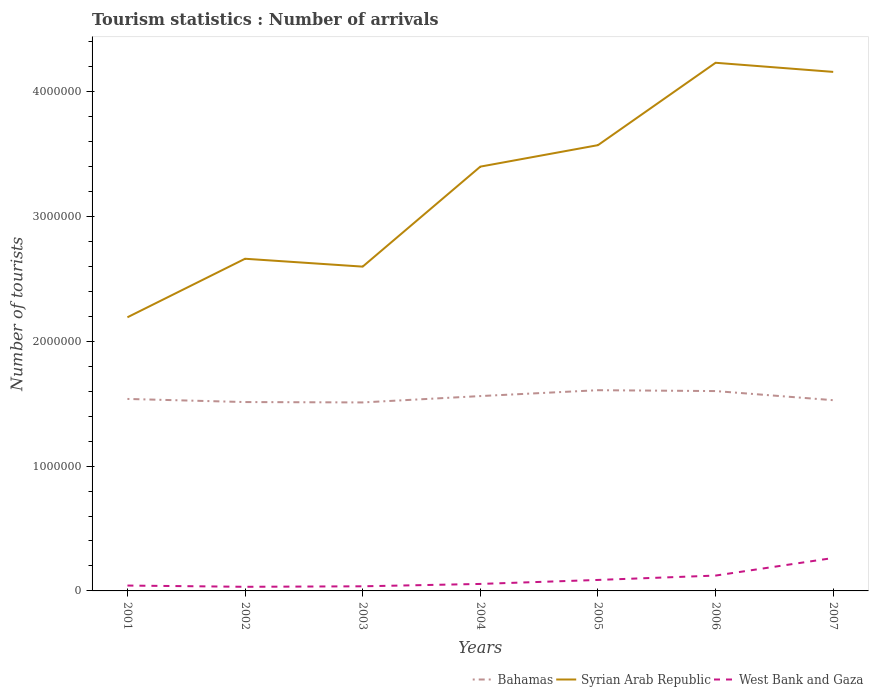Does the line corresponding to West Bank and Gaza intersect with the line corresponding to Syrian Arab Republic?
Your answer should be compact. No. Is the number of lines equal to the number of legend labels?
Make the answer very short. Yes. Across all years, what is the maximum number of tourist arrivals in Syrian Arab Republic?
Make the answer very short. 2.19e+06. What is the total number of tourist arrivals in West Bank and Gaza in the graph?
Your answer should be very brief. -4000. What is the difference between the highest and the second highest number of tourist arrivals in West Bank and Gaza?
Offer a very short reply. 2.31e+05. How many years are there in the graph?
Make the answer very short. 7. Does the graph contain any zero values?
Provide a short and direct response. No. Does the graph contain grids?
Provide a short and direct response. No. How many legend labels are there?
Keep it short and to the point. 3. What is the title of the graph?
Provide a succinct answer. Tourism statistics : Number of arrivals. Does "Suriname" appear as one of the legend labels in the graph?
Give a very brief answer. No. What is the label or title of the Y-axis?
Give a very brief answer. Number of tourists. What is the Number of tourists of Bahamas in 2001?
Offer a very short reply. 1.54e+06. What is the Number of tourists of Syrian Arab Republic in 2001?
Offer a terse response. 2.19e+06. What is the Number of tourists in West Bank and Gaza in 2001?
Provide a succinct answer. 4.30e+04. What is the Number of tourists of Bahamas in 2002?
Offer a terse response. 1.51e+06. What is the Number of tourists of Syrian Arab Republic in 2002?
Ensure brevity in your answer.  2.66e+06. What is the Number of tourists of West Bank and Gaza in 2002?
Keep it short and to the point. 3.30e+04. What is the Number of tourists in Bahamas in 2003?
Offer a terse response. 1.51e+06. What is the Number of tourists in Syrian Arab Republic in 2003?
Your answer should be very brief. 2.60e+06. What is the Number of tourists in West Bank and Gaza in 2003?
Offer a terse response. 3.70e+04. What is the Number of tourists in Bahamas in 2004?
Make the answer very short. 1.56e+06. What is the Number of tourists in Syrian Arab Republic in 2004?
Your response must be concise. 3.40e+06. What is the Number of tourists of West Bank and Gaza in 2004?
Ensure brevity in your answer.  5.60e+04. What is the Number of tourists in Bahamas in 2005?
Your answer should be very brief. 1.61e+06. What is the Number of tourists in Syrian Arab Republic in 2005?
Provide a short and direct response. 3.57e+06. What is the Number of tourists of West Bank and Gaza in 2005?
Your response must be concise. 8.80e+04. What is the Number of tourists in Bahamas in 2006?
Keep it short and to the point. 1.60e+06. What is the Number of tourists in Syrian Arab Republic in 2006?
Your response must be concise. 4.23e+06. What is the Number of tourists in West Bank and Gaza in 2006?
Provide a succinct answer. 1.23e+05. What is the Number of tourists in Bahamas in 2007?
Your answer should be very brief. 1.53e+06. What is the Number of tourists of Syrian Arab Republic in 2007?
Offer a terse response. 4.16e+06. What is the Number of tourists in West Bank and Gaza in 2007?
Your answer should be compact. 2.64e+05. Across all years, what is the maximum Number of tourists in Bahamas?
Your answer should be compact. 1.61e+06. Across all years, what is the maximum Number of tourists of Syrian Arab Republic?
Your response must be concise. 4.23e+06. Across all years, what is the maximum Number of tourists of West Bank and Gaza?
Provide a succinct answer. 2.64e+05. Across all years, what is the minimum Number of tourists of Bahamas?
Ensure brevity in your answer.  1.51e+06. Across all years, what is the minimum Number of tourists in Syrian Arab Republic?
Give a very brief answer. 2.19e+06. Across all years, what is the minimum Number of tourists in West Bank and Gaza?
Your answer should be very brief. 3.30e+04. What is the total Number of tourists of Bahamas in the graph?
Keep it short and to the point. 1.09e+07. What is the total Number of tourists in Syrian Arab Republic in the graph?
Provide a short and direct response. 2.28e+07. What is the total Number of tourists in West Bank and Gaza in the graph?
Your answer should be very brief. 6.44e+05. What is the difference between the Number of tourists in Bahamas in 2001 and that in 2002?
Give a very brief answer. 2.50e+04. What is the difference between the Number of tourists in Syrian Arab Republic in 2001 and that in 2002?
Your answer should be compact. -4.69e+05. What is the difference between the Number of tourists in West Bank and Gaza in 2001 and that in 2002?
Provide a short and direct response. 10000. What is the difference between the Number of tourists of Bahamas in 2001 and that in 2003?
Give a very brief answer. 2.80e+04. What is the difference between the Number of tourists in Syrian Arab Republic in 2001 and that in 2003?
Offer a very short reply. -4.06e+05. What is the difference between the Number of tourists in West Bank and Gaza in 2001 and that in 2003?
Provide a succinct answer. 6000. What is the difference between the Number of tourists in Bahamas in 2001 and that in 2004?
Ensure brevity in your answer.  -2.30e+04. What is the difference between the Number of tourists of Syrian Arab Republic in 2001 and that in 2004?
Offer a very short reply. -1.21e+06. What is the difference between the Number of tourists of West Bank and Gaza in 2001 and that in 2004?
Your answer should be compact. -1.30e+04. What is the difference between the Number of tourists of Syrian Arab Republic in 2001 and that in 2005?
Make the answer very short. -1.38e+06. What is the difference between the Number of tourists in West Bank and Gaza in 2001 and that in 2005?
Provide a short and direct response. -4.50e+04. What is the difference between the Number of tourists of Bahamas in 2001 and that in 2006?
Your answer should be very brief. -6.30e+04. What is the difference between the Number of tourists of Syrian Arab Republic in 2001 and that in 2006?
Your response must be concise. -2.04e+06. What is the difference between the Number of tourists in Syrian Arab Republic in 2001 and that in 2007?
Keep it short and to the point. -1.97e+06. What is the difference between the Number of tourists of West Bank and Gaza in 2001 and that in 2007?
Ensure brevity in your answer.  -2.21e+05. What is the difference between the Number of tourists in Bahamas in 2002 and that in 2003?
Offer a terse response. 3000. What is the difference between the Number of tourists of Syrian Arab Republic in 2002 and that in 2003?
Your answer should be very brief. 6.30e+04. What is the difference between the Number of tourists of West Bank and Gaza in 2002 and that in 2003?
Provide a short and direct response. -4000. What is the difference between the Number of tourists of Bahamas in 2002 and that in 2004?
Your response must be concise. -4.80e+04. What is the difference between the Number of tourists in Syrian Arab Republic in 2002 and that in 2004?
Provide a short and direct response. -7.38e+05. What is the difference between the Number of tourists of West Bank and Gaza in 2002 and that in 2004?
Your answer should be compact. -2.30e+04. What is the difference between the Number of tourists in Bahamas in 2002 and that in 2005?
Provide a succinct answer. -9.50e+04. What is the difference between the Number of tourists in Syrian Arab Republic in 2002 and that in 2005?
Make the answer very short. -9.10e+05. What is the difference between the Number of tourists of West Bank and Gaza in 2002 and that in 2005?
Your response must be concise. -5.50e+04. What is the difference between the Number of tourists of Bahamas in 2002 and that in 2006?
Ensure brevity in your answer.  -8.80e+04. What is the difference between the Number of tourists of Syrian Arab Republic in 2002 and that in 2006?
Provide a short and direct response. -1.57e+06. What is the difference between the Number of tourists in West Bank and Gaza in 2002 and that in 2006?
Make the answer very short. -9.00e+04. What is the difference between the Number of tourists in Bahamas in 2002 and that in 2007?
Offer a terse response. -1.50e+04. What is the difference between the Number of tourists of Syrian Arab Republic in 2002 and that in 2007?
Provide a succinct answer. -1.50e+06. What is the difference between the Number of tourists of West Bank and Gaza in 2002 and that in 2007?
Offer a terse response. -2.31e+05. What is the difference between the Number of tourists of Bahamas in 2003 and that in 2004?
Provide a succinct answer. -5.10e+04. What is the difference between the Number of tourists of Syrian Arab Republic in 2003 and that in 2004?
Make the answer very short. -8.01e+05. What is the difference between the Number of tourists in West Bank and Gaza in 2003 and that in 2004?
Your answer should be compact. -1.90e+04. What is the difference between the Number of tourists of Bahamas in 2003 and that in 2005?
Provide a short and direct response. -9.80e+04. What is the difference between the Number of tourists in Syrian Arab Republic in 2003 and that in 2005?
Give a very brief answer. -9.73e+05. What is the difference between the Number of tourists of West Bank and Gaza in 2003 and that in 2005?
Your answer should be compact. -5.10e+04. What is the difference between the Number of tourists in Bahamas in 2003 and that in 2006?
Provide a short and direct response. -9.10e+04. What is the difference between the Number of tourists in Syrian Arab Republic in 2003 and that in 2006?
Offer a very short reply. -1.63e+06. What is the difference between the Number of tourists of West Bank and Gaza in 2003 and that in 2006?
Offer a very short reply. -8.60e+04. What is the difference between the Number of tourists of Bahamas in 2003 and that in 2007?
Keep it short and to the point. -1.80e+04. What is the difference between the Number of tourists of Syrian Arab Republic in 2003 and that in 2007?
Give a very brief answer. -1.56e+06. What is the difference between the Number of tourists in West Bank and Gaza in 2003 and that in 2007?
Your answer should be very brief. -2.27e+05. What is the difference between the Number of tourists in Bahamas in 2004 and that in 2005?
Give a very brief answer. -4.70e+04. What is the difference between the Number of tourists of Syrian Arab Republic in 2004 and that in 2005?
Your answer should be very brief. -1.72e+05. What is the difference between the Number of tourists in West Bank and Gaza in 2004 and that in 2005?
Offer a terse response. -3.20e+04. What is the difference between the Number of tourists in Syrian Arab Republic in 2004 and that in 2006?
Provide a short and direct response. -8.32e+05. What is the difference between the Number of tourists in West Bank and Gaza in 2004 and that in 2006?
Keep it short and to the point. -6.70e+04. What is the difference between the Number of tourists in Bahamas in 2004 and that in 2007?
Offer a terse response. 3.30e+04. What is the difference between the Number of tourists of Syrian Arab Republic in 2004 and that in 2007?
Provide a short and direct response. -7.59e+05. What is the difference between the Number of tourists of West Bank and Gaza in 2004 and that in 2007?
Your answer should be very brief. -2.08e+05. What is the difference between the Number of tourists in Bahamas in 2005 and that in 2006?
Your response must be concise. 7000. What is the difference between the Number of tourists of Syrian Arab Republic in 2005 and that in 2006?
Offer a very short reply. -6.60e+05. What is the difference between the Number of tourists in West Bank and Gaza in 2005 and that in 2006?
Your answer should be compact. -3.50e+04. What is the difference between the Number of tourists in Syrian Arab Republic in 2005 and that in 2007?
Provide a succinct answer. -5.87e+05. What is the difference between the Number of tourists in West Bank and Gaza in 2005 and that in 2007?
Offer a very short reply. -1.76e+05. What is the difference between the Number of tourists in Bahamas in 2006 and that in 2007?
Make the answer very short. 7.30e+04. What is the difference between the Number of tourists in Syrian Arab Republic in 2006 and that in 2007?
Offer a terse response. 7.30e+04. What is the difference between the Number of tourists of West Bank and Gaza in 2006 and that in 2007?
Keep it short and to the point. -1.41e+05. What is the difference between the Number of tourists of Bahamas in 2001 and the Number of tourists of Syrian Arab Republic in 2002?
Ensure brevity in your answer.  -1.12e+06. What is the difference between the Number of tourists of Bahamas in 2001 and the Number of tourists of West Bank and Gaza in 2002?
Make the answer very short. 1.50e+06. What is the difference between the Number of tourists of Syrian Arab Republic in 2001 and the Number of tourists of West Bank and Gaza in 2002?
Give a very brief answer. 2.16e+06. What is the difference between the Number of tourists in Bahamas in 2001 and the Number of tourists in Syrian Arab Republic in 2003?
Provide a succinct answer. -1.06e+06. What is the difference between the Number of tourists in Bahamas in 2001 and the Number of tourists in West Bank and Gaza in 2003?
Make the answer very short. 1.50e+06. What is the difference between the Number of tourists in Syrian Arab Republic in 2001 and the Number of tourists in West Bank and Gaza in 2003?
Provide a succinct answer. 2.16e+06. What is the difference between the Number of tourists in Bahamas in 2001 and the Number of tourists in Syrian Arab Republic in 2004?
Give a very brief answer. -1.86e+06. What is the difference between the Number of tourists of Bahamas in 2001 and the Number of tourists of West Bank and Gaza in 2004?
Make the answer very short. 1.48e+06. What is the difference between the Number of tourists in Syrian Arab Republic in 2001 and the Number of tourists in West Bank and Gaza in 2004?
Provide a succinct answer. 2.14e+06. What is the difference between the Number of tourists in Bahamas in 2001 and the Number of tourists in Syrian Arab Republic in 2005?
Your answer should be compact. -2.03e+06. What is the difference between the Number of tourists in Bahamas in 2001 and the Number of tourists in West Bank and Gaza in 2005?
Your response must be concise. 1.45e+06. What is the difference between the Number of tourists in Syrian Arab Republic in 2001 and the Number of tourists in West Bank and Gaza in 2005?
Your answer should be compact. 2.10e+06. What is the difference between the Number of tourists of Bahamas in 2001 and the Number of tourists of Syrian Arab Republic in 2006?
Make the answer very short. -2.69e+06. What is the difference between the Number of tourists of Bahamas in 2001 and the Number of tourists of West Bank and Gaza in 2006?
Your response must be concise. 1.42e+06. What is the difference between the Number of tourists of Syrian Arab Republic in 2001 and the Number of tourists of West Bank and Gaza in 2006?
Keep it short and to the point. 2.07e+06. What is the difference between the Number of tourists in Bahamas in 2001 and the Number of tourists in Syrian Arab Republic in 2007?
Your answer should be very brief. -2.62e+06. What is the difference between the Number of tourists in Bahamas in 2001 and the Number of tourists in West Bank and Gaza in 2007?
Offer a very short reply. 1.27e+06. What is the difference between the Number of tourists in Syrian Arab Republic in 2001 and the Number of tourists in West Bank and Gaza in 2007?
Keep it short and to the point. 1.93e+06. What is the difference between the Number of tourists in Bahamas in 2002 and the Number of tourists in Syrian Arab Republic in 2003?
Give a very brief answer. -1.08e+06. What is the difference between the Number of tourists of Bahamas in 2002 and the Number of tourists of West Bank and Gaza in 2003?
Provide a short and direct response. 1.48e+06. What is the difference between the Number of tourists in Syrian Arab Republic in 2002 and the Number of tourists in West Bank and Gaza in 2003?
Keep it short and to the point. 2.62e+06. What is the difference between the Number of tourists of Bahamas in 2002 and the Number of tourists of Syrian Arab Republic in 2004?
Offer a very short reply. -1.89e+06. What is the difference between the Number of tourists of Bahamas in 2002 and the Number of tourists of West Bank and Gaza in 2004?
Your answer should be very brief. 1.46e+06. What is the difference between the Number of tourists of Syrian Arab Republic in 2002 and the Number of tourists of West Bank and Gaza in 2004?
Make the answer very short. 2.60e+06. What is the difference between the Number of tourists in Bahamas in 2002 and the Number of tourists in Syrian Arab Republic in 2005?
Offer a very short reply. -2.06e+06. What is the difference between the Number of tourists of Bahamas in 2002 and the Number of tourists of West Bank and Gaza in 2005?
Provide a short and direct response. 1.42e+06. What is the difference between the Number of tourists of Syrian Arab Republic in 2002 and the Number of tourists of West Bank and Gaza in 2005?
Make the answer very short. 2.57e+06. What is the difference between the Number of tourists in Bahamas in 2002 and the Number of tourists in Syrian Arab Republic in 2006?
Give a very brief answer. -2.72e+06. What is the difference between the Number of tourists in Bahamas in 2002 and the Number of tourists in West Bank and Gaza in 2006?
Offer a very short reply. 1.39e+06. What is the difference between the Number of tourists of Syrian Arab Republic in 2002 and the Number of tourists of West Bank and Gaza in 2006?
Your answer should be very brief. 2.54e+06. What is the difference between the Number of tourists in Bahamas in 2002 and the Number of tourists in Syrian Arab Republic in 2007?
Keep it short and to the point. -2.64e+06. What is the difference between the Number of tourists of Bahamas in 2002 and the Number of tourists of West Bank and Gaza in 2007?
Give a very brief answer. 1.25e+06. What is the difference between the Number of tourists of Syrian Arab Republic in 2002 and the Number of tourists of West Bank and Gaza in 2007?
Your answer should be compact. 2.40e+06. What is the difference between the Number of tourists in Bahamas in 2003 and the Number of tourists in Syrian Arab Republic in 2004?
Provide a succinct answer. -1.89e+06. What is the difference between the Number of tourists in Bahamas in 2003 and the Number of tourists in West Bank and Gaza in 2004?
Offer a terse response. 1.45e+06. What is the difference between the Number of tourists in Syrian Arab Republic in 2003 and the Number of tourists in West Bank and Gaza in 2004?
Give a very brief answer. 2.54e+06. What is the difference between the Number of tourists of Bahamas in 2003 and the Number of tourists of Syrian Arab Republic in 2005?
Keep it short and to the point. -2.06e+06. What is the difference between the Number of tourists in Bahamas in 2003 and the Number of tourists in West Bank and Gaza in 2005?
Your answer should be very brief. 1.42e+06. What is the difference between the Number of tourists in Syrian Arab Republic in 2003 and the Number of tourists in West Bank and Gaza in 2005?
Offer a terse response. 2.51e+06. What is the difference between the Number of tourists in Bahamas in 2003 and the Number of tourists in Syrian Arab Republic in 2006?
Offer a very short reply. -2.72e+06. What is the difference between the Number of tourists in Bahamas in 2003 and the Number of tourists in West Bank and Gaza in 2006?
Give a very brief answer. 1.39e+06. What is the difference between the Number of tourists of Syrian Arab Republic in 2003 and the Number of tourists of West Bank and Gaza in 2006?
Offer a very short reply. 2.48e+06. What is the difference between the Number of tourists in Bahamas in 2003 and the Number of tourists in Syrian Arab Republic in 2007?
Keep it short and to the point. -2.65e+06. What is the difference between the Number of tourists of Bahamas in 2003 and the Number of tourists of West Bank and Gaza in 2007?
Provide a succinct answer. 1.25e+06. What is the difference between the Number of tourists in Syrian Arab Republic in 2003 and the Number of tourists in West Bank and Gaza in 2007?
Your response must be concise. 2.33e+06. What is the difference between the Number of tourists of Bahamas in 2004 and the Number of tourists of Syrian Arab Republic in 2005?
Ensure brevity in your answer.  -2.01e+06. What is the difference between the Number of tourists in Bahamas in 2004 and the Number of tourists in West Bank and Gaza in 2005?
Ensure brevity in your answer.  1.47e+06. What is the difference between the Number of tourists in Syrian Arab Republic in 2004 and the Number of tourists in West Bank and Gaza in 2005?
Keep it short and to the point. 3.31e+06. What is the difference between the Number of tourists in Bahamas in 2004 and the Number of tourists in Syrian Arab Republic in 2006?
Your answer should be compact. -2.67e+06. What is the difference between the Number of tourists in Bahamas in 2004 and the Number of tourists in West Bank and Gaza in 2006?
Offer a very short reply. 1.44e+06. What is the difference between the Number of tourists of Syrian Arab Republic in 2004 and the Number of tourists of West Bank and Gaza in 2006?
Your answer should be compact. 3.28e+06. What is the difference between the Number of tourists in Bahamas in 2004 and the Number of tourists in Syrian Arab Republic in 2007?
Your response must be concise. -2.60e+06. What is the difference between the Number of tourists in Bahamas in 2004 and the Number of tourists in West Bank and Gaza in 2007?
Keep it short and to the point. 1.30e+06. What is the difference between the Number of tourists in Syrian Arab Republic in 2004 and the Number of tourists in West Bank and Gaza in 2007?
Your answer should be compact. 3.14e+06. What is the difference between the Number of tourists in Bahamas in 2005 and the Number of tourists in Syrian Arab Republic in 2006?
Ensure brevity in your answer.  -2.62e+06. What is the difference between the Number of tourists of Bahamas in 2005 and the Number of tourists of West Bank and Gaza in 2006?
Keep it short and to the point. 1.48e+06. What is the difference between the Number of tourists in Syrian Arab Republic in 2005 and the Number of tourists in West Bank and Gaza in 2006?
Ensure brevity in your answer.  3.45e+06. What is the difference between the Number of tourists of Bahamas in 2005 and the Number of tourists of Syrian Arab Republic in 2007?
Make the answer very short. -2.55e+06. What is the difference between the Number of tourists in Bahamas in 2005 and the Number of tourists in West Bank and Gaza in 2007?
Offer a terse response. 1.34e+06. What is the difference between the Number of tourists in Syrian Arab Republic in 2005 and the Number of tourists in West Bank and Gaza in 2007?
Provide a short and direct response. 3.31e+06. What is the difference between the Number of tourists of Bahamas in 2006 and the Number of tourists of Syrian Arab Republic in 2007?
Offer a terse response. -2.56e+06. What is the difference between the Number of tourists in Bahamas in 2006 and the Number of tourists in West Bank and Gaza in 2007?
Your answer should be compact. 1.34e+06. What is the difference between the Number of tourists of Syrian Arab Republic in 2006 and the Number of tourists of West Bank and Gaza in 2007?
Offer a terse response. 3.97e+06. What is the average Number of tourists in Bahamas per year?
Provide a succinct answer. 1.55e+06. What is the average Number of tourists in Syrian Arab Republic per year?
Provide a succinct answer. 3.26e+06. What is the average Number of tourists in West Bank and Gaza per year?
Give a very brief answer. 9.20e+04. In the year 2001, what is the difference between the Number of tourists of Bahamas and Number of tourists of Syrian Arab Republic?
Your answer should be very brief. -6.54e+05. In the year 2001, what is the difference between the Number of tourists in Bahamas and Number of tourists in West Bank and Gaza?
Give a very brief answer. 1.50e+06. In the year 2001, what is the difference between the Number of tourists in Syrian Arab Republic and Number of tourists in West Bank and Gaza?
Keep it short and to the point. 2.15e+06. In the year 2002, what is the difference between the Number of tourists of Bahamas and Number of tourists of Syrian Arab Republic?
Offer a very short reply. -1.15e+06. In the year 2002, what is the difference between the Number of tourists in Bahamas and Number of tourists in West Bank and Gaza?
Make the answer very short. 1.48e+06. In the year 2002, what is the difference between the Number of tourists in Syrian Arab Republic and Number of tourists in West Bank and Gaza?
Ensure brevity in your answer.  2.63e+06. In the year 2003, what is the difference between the Number of tourists of Bahamas and Number of tourists of Syrian Arab Republic?
Give a very brief answer. -1.09e+06. In the year 2003, what is the difference between the Number of tourists of Bahamas and Number of tourists of West Bank and Gaza?
Your answer should be very brief. 1.47e+06. In the year 2003, what is the difference between the Number of tourists of Syrian Arab Republic and Number of tourists of West Bank and Gaza?
Offer a very short reply. 2.56e+06. In the year 2004, what is the difference between the Number of tourists in Bahamas and Number of tourists in Syrian Arab Republic?
Provide a short and direct response. -1.84e+06. In the year 2004, what is the difference between the Number of tourists in Bahamas and Number of tourists in West Bank and Gaza?
Your answer should be compact. 1.50e+06. In the year 2004, what is the difference between the Number of tourists of Syrian Arab Republic and Number of tourists of West Bank and Gaza?
Ensure brevity in your answer.  3.34e+06. In the year 2005, what is the difference between the Number of tourists of Bahamas and Number of tourists of Syrian Arab Republic?
Your response must be concise. -1.96e+06. In the year 2005, what is the difference between the Number of tourists in Bahamas and Number of tourists in West Bank and Gaza?
Your response must be concise. 1.52e+06. In the year 2005, what is the difference between the Number of tourists of Syrian Arab Republic and Number of tourists of West Bank and Gaza?
Your answer should be compact. 3.48e+06. In the year 2006, what is the difference between the Number of tourists in Bahamas and Number of tourists in Syrian Arab Republic?
Provide a short and direct response. -2.63e+06. In the year 2006, what is the difference between the Number of tourists in Bahamas and Number of tourists in West Bank and Gaza?
Give a very brief answer. 1.48e+06. In the year 2006, what is the difference between the Number of tourists of Syrian Arab Republic and Number of tourists of West Bank and Gaza?
Make the answer very short. 4.11e+06. In the year 2007, what is the difference between the Number of tourists in Bahamas and Number of tourists in Syrian Arab Republic?
Give a very brief answer. -2.63e+06. In the year 2007, what is the difference between the Number of tourists in Bahamas and Number of tourists in West Bank and Gaza?
Provide a succinct answer. 1.26e+06. In the year 2007, what is the difference between the Number of tourists in Syrian Arab Republic and Number of tourists in West Bank and Gaza?
Offer a terse response. 3.89e+06. What is the ratio of the Number of tourists in Bahamas in 2001 to that in 2002?
Keep it short and to the point. 1.02. What is the ratio of the Number of tourists in Syrian Arab Republic in 2001 to that in 2002?
Your answer should be very brief. 0.82. What is the ratio of the Number of tourists of West Bank and Gaza in 2001 to that in 2002?
Your answer should be very brief. 1.3. What is the ratio of the Number of tourists in Bahamas in 2001 to that in 2003?
Give a very brief answer. 1.02. What is the ratio of the Number of tourists in Syrian Arab Republic in 2001 to that in 2003?
Your response must be concise. 0.84. What is the ratio of the Number of tourists of West Bank and Gaza in 2001 to that in 2003?
Offer a terse response. 1.16. What is the ratio of the Number of tourists of Syrian Arab Republic in 2001 to that in 2004?
Make the answer very short. 0.64. What is the ratio of the Number of tourists of West Bank and Gaza in 2001 to that in 2004?
Your answer should be very brief. 0.77. What is the ratio of the Number of tourists of Bahamas in 2001 to that in 2005?
Your answer should be very brief. 0.96. What is the ratio of the Number of tourists of Syrian Arab Republic in 2001 to that in 2005?
Give a very brief answer. 0.61. What is the ratio of the Number of tourists in West Bank and Gaza in 2001 to that in 2005?
Your response must be concise. 0.49. What is the ratio of the Number of tourists in Bahamas in 2001 to that in 2006?
Offer a terse response. 0.96. What is the ratio of the Number of tourists of Syrian Arab Republic in 2001 to that in 2006?
Keep it short and to the point. 0.52. What is the ratio of the Number of tourists in West Bank and Gaza in 2001 to that in 2006?
Provide a short and direct response. 0.35. What is the ratio of the Number of tourists in Syrian Arab Republic in 2001 to that in 2007?
Provide a succinct answer. 0.53. What is the ratio of the Number of tourists in West Bank and Gaza in 2001 to that in 2007?
Make the answer very short. 0.16. What is the ratio of the Number of tourists in Syrian Arab Republic in 2002 to that in 2003?
Offer a terse response. 1.02. What is the ratio of the Number of tourists of West Bank and Gaza in 2002 to that in 2003?
Offer a terse response. 0.89. What is the ratio of the Number of tourists in Bahamas in 2002 to that in 2004?
Your response must be concise. 0.97. What is the ratio of the Number of tourists in Syrian Arab Republic in 2002 to that in 2004?
Provide a succinct answer. 0.78. What is the ratio of the Number of tourists of West Bank and Gaza in 2002 to that in 2004?
Give a very brief answer. 0.59. What is the ratio of the Number of tourists of Bahamas in 2002 to that in 2005?
Your answer should be very brief. 0.94. What is the ratio of the Number of tourists in Syrian Arab Republic in 2002 to that in 2005?
Keep it short and to the point. 0.75. What is the ratio of the Number of tourists of West Bank and Gaza in 2002 to that in 2005?
Make the answer very short. 0.38. What is the ratio of the Number of tourists of Bahamas in 2002 to that in 2006?
Keep it short and to the point. 0.94. What is the ratio of the Number of tourists in Syrian Arab Republic in 2002 to that in 2006?
Provide a succinct answer. 0.63. What is the ratio of the Number of tourists in West Bank and Gaza in 2002 to that in 2006?
Provide a succinct answer. 0.27. What is the ratio of the Number of tourists in Bahamas in 2002 to that in 2007?
Give a very brief answer. 0.99. What is the ratio of the Number of tourists of Syrian Arab Republic in 2002 to that in 2007?
Give a very brief answer. 0.64. What is the ratio of the Number of tourists in Bahamas in 2003 to that in 2004?
Your answer should be very brief. 0.97. What is the ratio of the Number of tourists in Syrian Arab Republic in 2003 to that in 2004?
Provide a short and direct response. 0.76. What is the ratio of the Number of tourists in West Bank and Gaza in 2003 to that in 2004?
Provide a succinct answer. 0.66. What is the ratio of the Number of tourists of Bahamas in 2003 to that in 2005?
Provide a short and direct response. 0.94. What is the ratio of the Number of tourists of Syrian Arab Republic in 2003 to that in 2005?
Your answer should be very brief. 0.73. What is the ratio of the Number of tourists of West Bank and Gaza in 2003 to that in 2005?
Make the answer very short. 0.42. What is the ratio of the Number of tourists in Bahamas in 2003 to that in 2006?
Ensure brevity in your answer.  0.94. What is the ratio of the Number of tourists in Syrian Arab Republic in 2003 to that in 2006?
Offer a very short reply. 0.61. What is the ratio of the Number of tourists in West Bank and Gaza in 2003 to that in 2006?
Offer a terse response. 0.3. What is the ratio of the Number of tourists in Syrian Arab Republic in 2003 to that in 2007?
Provide a succinct answer. 0.62. What is the ratio of the Number of tourists of West Bank and Gaza in 2003 to that in 2007?
Your answer should be very brief. 0.14. What is the ratio of the Number of tourists in Bahamas in 2004 to that in 2005?
Offer a very short reply. 0.97. What is the ratio of the Number of tourists of Syrian Arab Republic in 2004 to that in 2005?
Offer a terse response. 0.95. What is the ratio of the Number of tourists in West Bank and Gaza in 2004 to that in 2005?
Your answer should be very brief. 0.64. What is the ratio of the Number of tourists of Syrian Arab Republic in 2004 to that in 2006?
Provide a short and direct response. 0.8. What is the ratio of the Number of tourists of West Bank and Gaza in 2004 to that in 2006?
Keep it short and to the point. 0.46. What is the ratio of the Number of tourists in Bahamas in 2004 to that in 2007?
Your answer should be compact. 1.02. What is the ratio of the Number of tourists in Syrian Arab Republic in 2004 to that in 2007?
Ensure brevity in your answer.  0.82. What is the ratio of the Number of tourists of West Bank and Gaza in 2004 to that in 2007?
Offer a terse response. 0.21. What is the ratio of the Number of tourists in Syrian Arab Republic in 2005 to that in 2006?
Provide a short and direct response. 0.84. What is the ratio of the Number of tourists of West Bank and Gaza in 2005 to that in 2006?
Offer a very short reply. 0.72. What is the ratio of the Number of tourists in Bahamas in 2005 to that in 2007?
Your answer should be compact. 1.05. What is the ratio of the Number of tourists of Syrian Arab Republic in 2005 to that in 2007?
Offer a very short reply. 0.86. What is the ratio of the Number of tourists in Bahamas in 2006 to that in 2007?
Give a very brief answer. 1.05. What is the ratio of the Number of tourists of Syrian Arab Republic in 2006 to that in 2007?
Your answer should be very brief. 1.02. What is the ratio of the Number of tourists of West Bank and Gaza in 2006 to that in 2007?
Provide a short and direct response. 0.47. What is the difference between the highest and the second highest Number of tourists in Bahamas?
Provide a short and direct response. 7000. What is the difference between the highest and the second highest Number of tourists of Syrian Arab Republic?
Give a very brief answer. 7.30e+04. What is the difference between the highest and the second highest Number of tourists in West Bank and Gaza?
Your response must be concise. 1.41e+05. What is the difference between the highest and the lowest Number of tourists in Bahamas?
Your answer should be very brief. 9.80e+04. What is the difference between the highest and the lowest Number of tourists in Syrian Arab Republic?
Your answer should be very brief. 2.04e+06. What is the difference between the highest and the lowest Number of tourists of West Bank and Gaza?
Your response must be concise. 2.31e+05. 